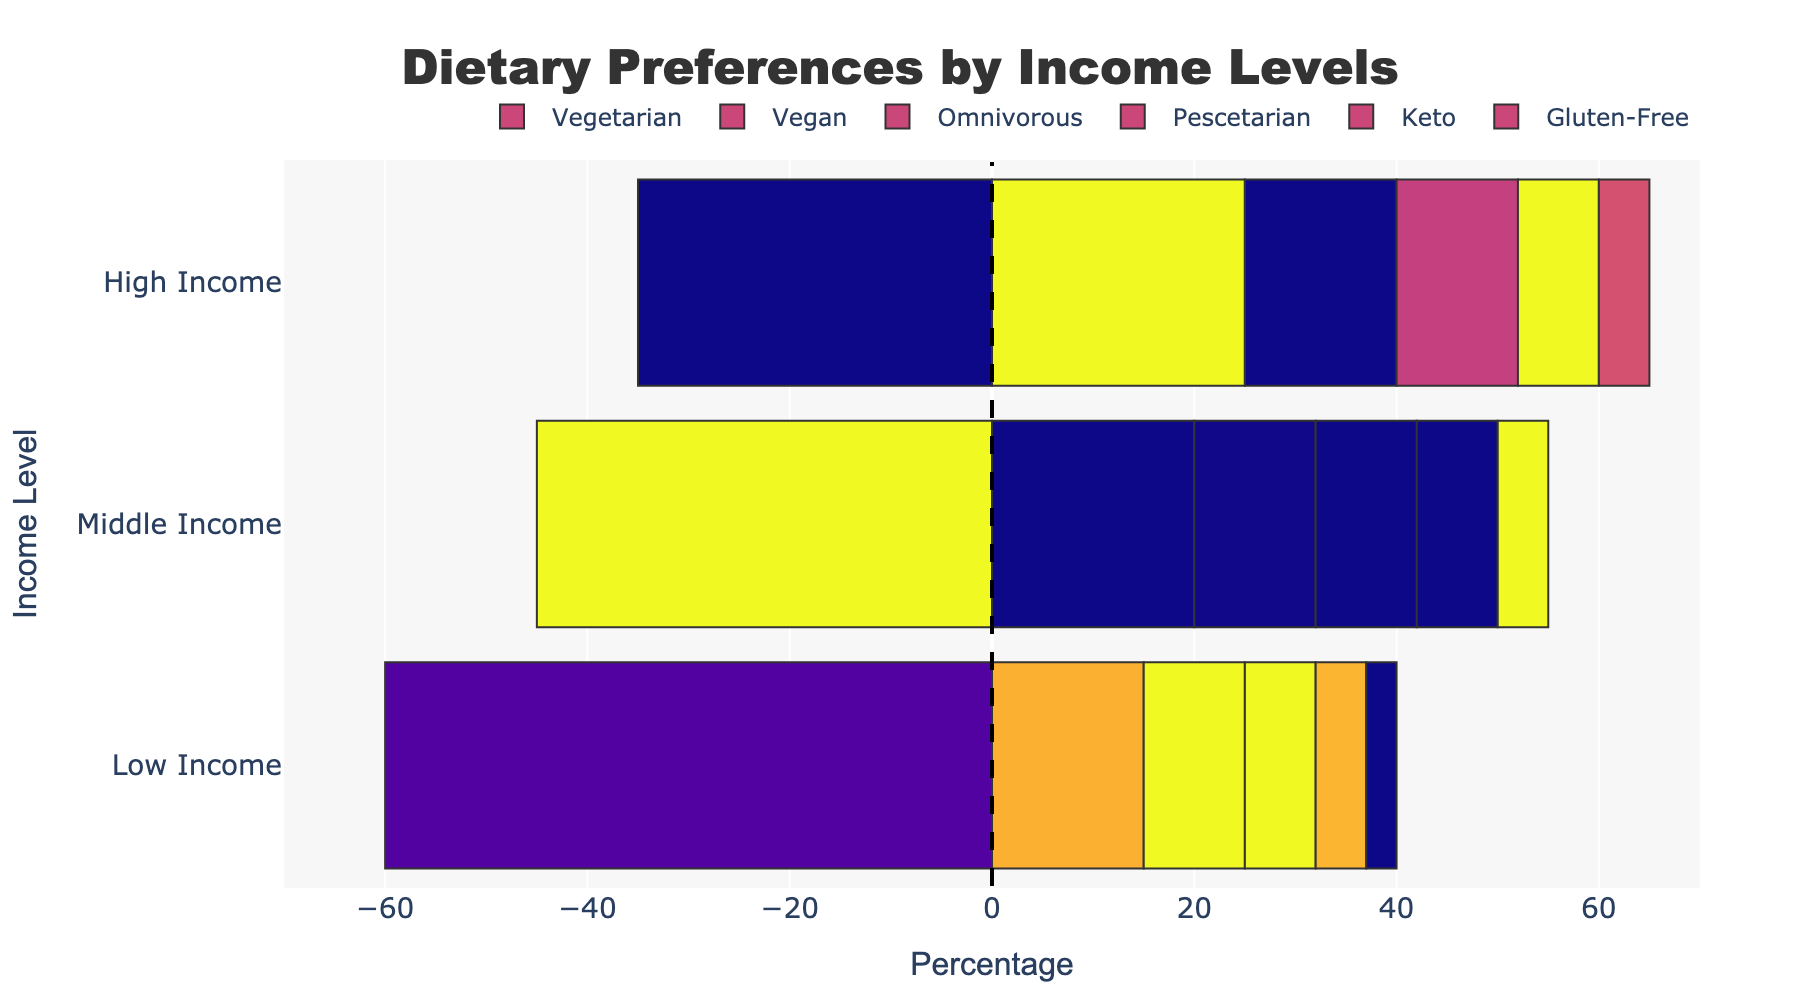Which income level has the highest percentage of vegetarians? Looking at the 'Vegetarian' bars, the high-income group has the longest bar and the highest percentage.
Answer: High-income Which dietary preference is the most common among low-income individuals? By comparing the lengths of the bars for low-income individuals, omnivorous has the longest bar.
Answer: Omnivorous How much higher is the percentage of vegans in high-income compared to low-income groups? The vegan percentage in high-income is 15%, and in low-income, it is 10%. The difference is 15% - 10%.
Answer: 5% What's the combined percentage of vegetarians and pescetarians in the middle-income group? Add the percentages of vegetarians (20%) and pescetarians (10%) in the middle-income group: 20% + 10%.
Answer: 30% Which dietary preference shows the least variation across income levels? By comparing the lengths of all the bars across income levels, 'Gluten-Free' shows the least variation being consistently low (3% to 5%).
Answer: Gluten-Free What is the average percentage of keto followers across all income levels? Sum the percentages of keto followers (5%, 8%, 8%) and divide by the number of income levels (3). Calculation: (5 + 8 + 8) / 3.
Answer: 7% What is the percentage difference between omnivorous individuals in middle-income vs. low-income categories? For middle-income, it's 45%; for low-income, it's 60%. The difference is 60% - 45%.
Answer: 15% Which dietary preference is least common in high-income groups? The shortest bar in the high-income category corresponds to the preference 'Gluten-Free', which has a percentage of 5%.
Answer: Gluten-Free By how much does the percentage of pescetarians increase from low-income to high-income groups? The percentage of pescetarians in low-income is 7%, and in high-income, it's 12%. The increase is 12% - 7%.
Answer: 5% What are the total percentages for all dietary preferences in each income group? For low-income: 15 + 10 + 60 + 7 + 5 + 3 = 100%. For middle-income: 20 + 12 + 45 + 10 + 8 + 5 = 100%. For high-income: 25 + 15 + 35 + 12 + 8 + 5 = 100%.
Answer: 100% 